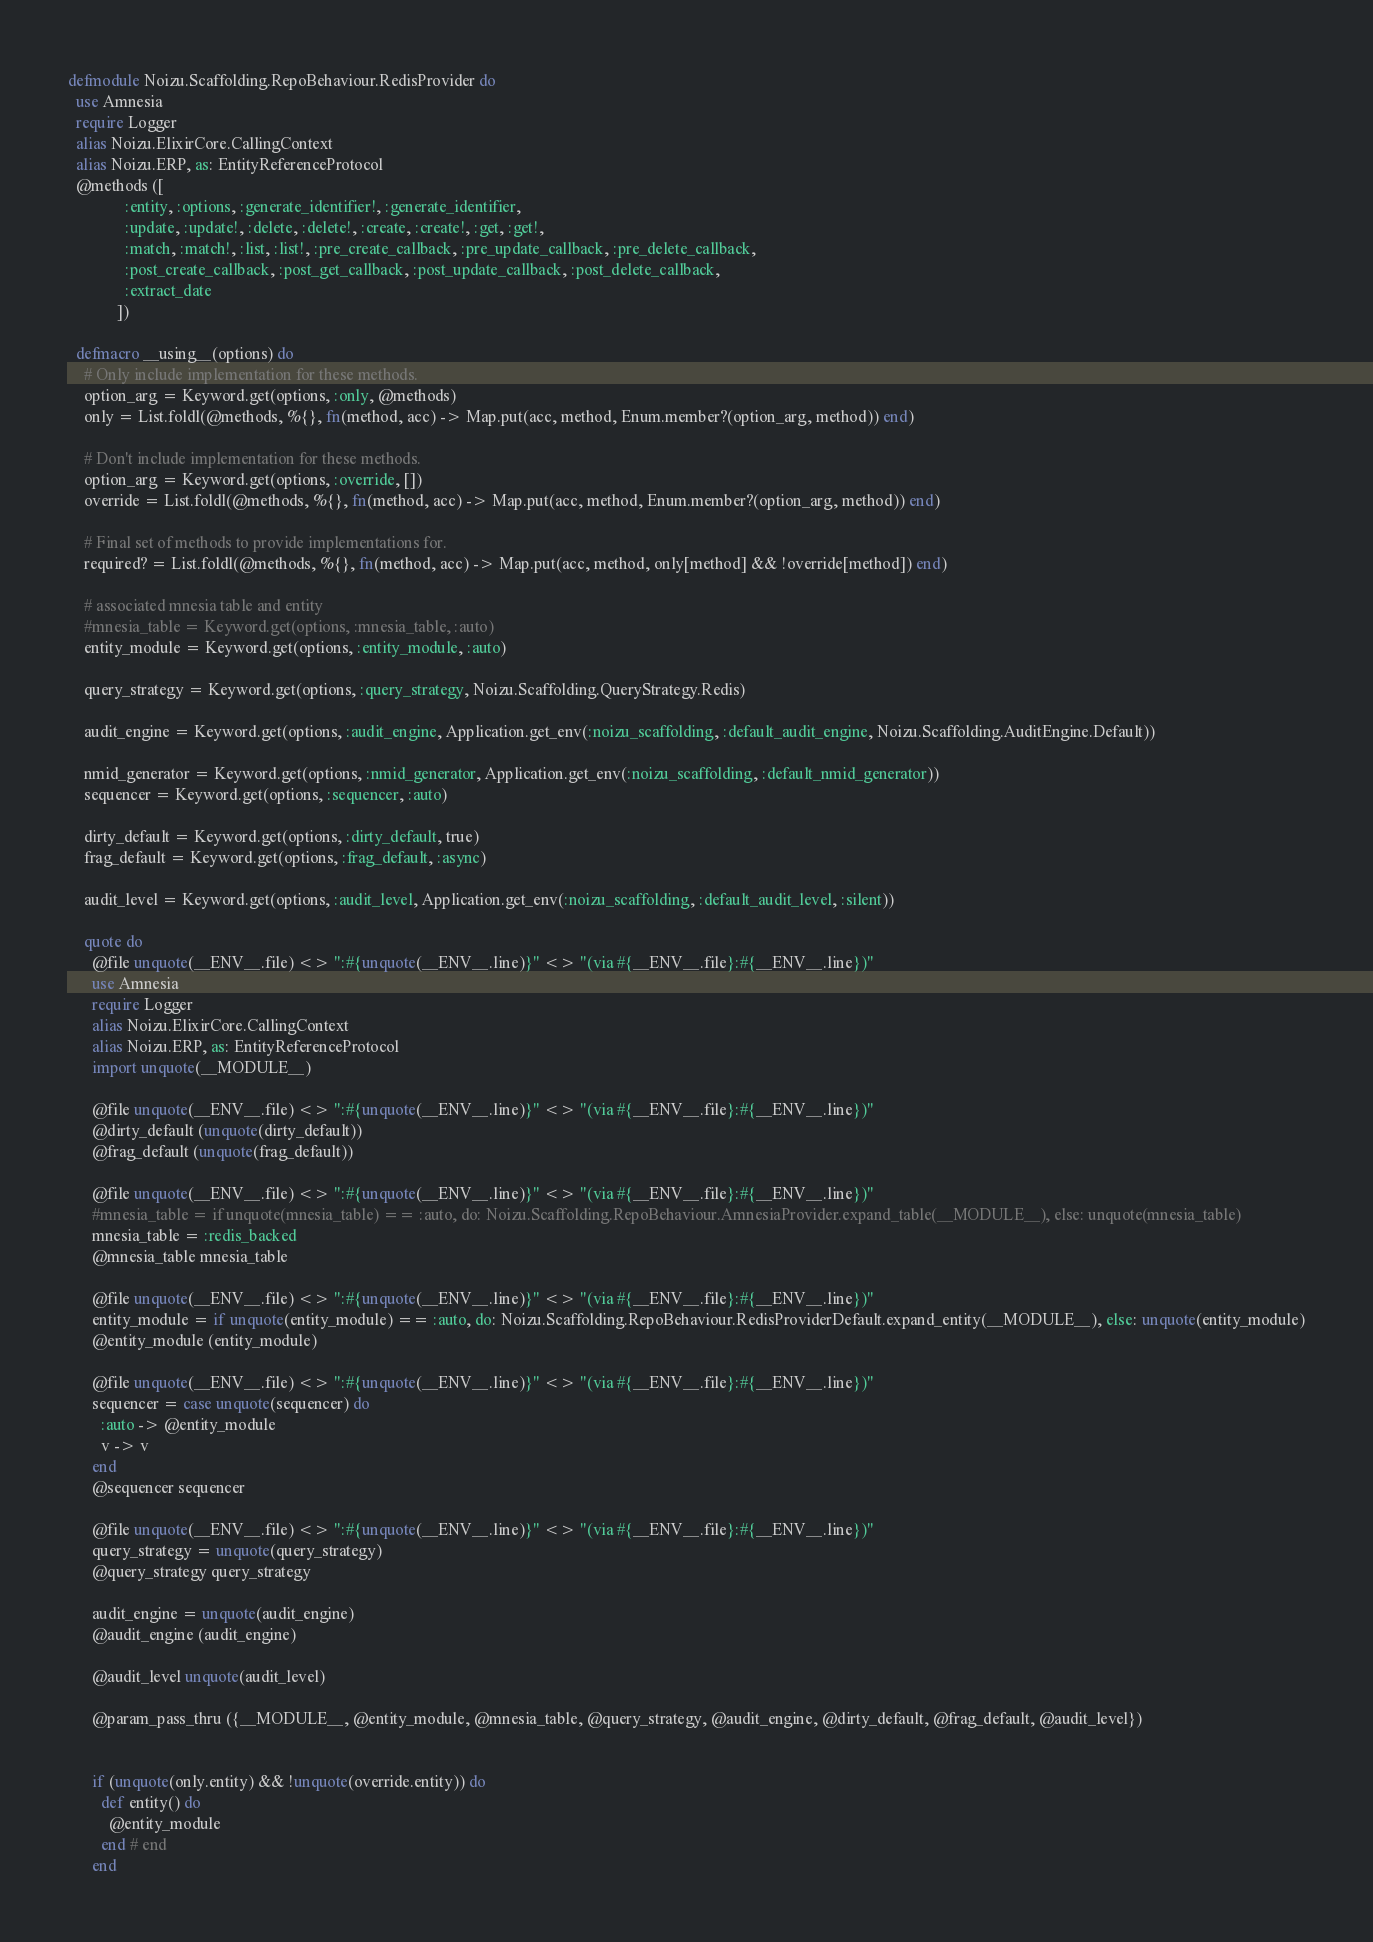<code> <loc_0><loc_0><loc_500><loc_500><_Elixir_>defmodule Noizu.Scaffolding.RepoBehaviour.RedisProvider do
  use Amnesia
  require Logger
  alias Noizu.ElixirCore.CallingContext
  alias Noizu.ERP, as: EntityReferenceProtocol
  @methods ([
              :entity, :options, :generate_identifier!, :generate_identifier,
              :update, :update!, :delete, :delete!, :create, :create!, :get, :get!,
              :match, :match!, :list, :list!, :pre_create_callback, :pre_update_callback, :pre_delete_callback,
              :post_create_callback, :post_get_callback, :post_update_callback, :post_delete_callback,
              :extract_date
            ])

  defmacro __using__(options) do
    # Only include implementation for these methods.
    option_arg = Keyword.get(options, :only, @methods)
    only = List.foldl(@methods, %{}, fn(method, acc) -> Map.put(acc, method, Enum.member?(option_arg, method)) end)

    # Don't include implementation for these methods.
    option_arg = Keyword.get(options, :override, [])
    override = List.foldl(@methods, %{}, fn(method, acc) -> Map.put(acc, method, Enum.member?(option_arg, method)) end)

    # Final set of methods to provide implementations for.
    required? = List.foldl(@methods, %{}, fn(method, acc) -> Map.put(acc, method, only[method] && !override[method]) end)

    # associated mnesia table and entity
    #mnesia_table = Keyword.get(options, :mnesia_table, :auto)
    entity_module = Keyword.get(options, :entity_module, :auto)

    query_strategy = Keyword.get(options, :query_strategy, Noizu.Scaffolding.QueryStrategy.Redis)

    audit_engine = Keyword.get(options, :audit_engine, Application.get_env(:noizu_scaffolding, :default_audit_engine, Noizu.Scaffolding.AuditEngine.Default))

    nmid_generator = Keyword.get(options, :nmid_generator, Application.get_env(:noizu_scaffolding, :default_nmid_generator))
    sequencer = Keyword.get(options, :sequencer, :auto)

    dirty_default = Keyword.get(options, :dirty_default, true)
    frag_default = Keyword.get(options, :frag_default, :async)

    audit_level = Keyword.get(options, :audit_level, Application.get_env(:noizu_scaffolding, :default_audit_level, :silent))

    quote do
      @file unquote(__ENV__.file) <> ":#{unquote(__ENV__.line)}" <> "(via #{__ENV__.file}:#{__ENV__.line})"
      use Amnesia
      require Logger
      alias Noizu.ElixirCore.CallingContext
      alias Noizu.ERP, as: EntityReferenceProtocol
      import unquote(__MODULE__)

      @file unquote(__ENV__.file) <> ":#{unquote(__ENV__.line)}" <> "(via #{__ENV__.file}:#{__ENV__.line})"
      @dirty_default (unquote(dirty_default))
      @frag_default (unquote(frag_default))

      @file unquote(__ENV__.file) <> ":#{unquote(__ENV__.line)}" <> "(via #{__ENV__.file}:#{__ENV__.line})"
      #mnesia_table = if unquote(mnesia_table) == :auto, do: Noizu.Scaffolding.RepoBehaviour.AmnesiaProvider.expand_table(__MODULE__), else: unquote(mnesia_table)
      mnesia_table = :redis_backed
      @mnesia_table mnesia_table

      @file unquote(__ENV__.file) <> ":#{unquote(__ENV__.line)}" <> "(via #{__ENV__.file}:#{__ENV__.line})"
      entity_module = if unquote(entity_module) == :auto, do: Noizu.Scaffolding.RepoBehaviour.RedisProviderDefault.expand_entity(__MODULE__), else: unquote(entity_module)
      @entity_module (entity_module)

      @file unquote(__ENV__.file) <> ":#{unquote(__ENV__.line)}" <> "(via #{__ENV__.file}:#{__ENV__.line})"
      sequencer = case unquote(sequencer) do
        :auto -> @entity_module
        v -> v
      end
      @sequencer sequencer

      @file unquote(__ENV__.file) <> ":#{unquote(__ENV__.line)}" <> "(via #{__ENV__.file}:#{__ENV__.line})"
      query_strategy = unquote(query_strategy)
      @query_strategy query_strategy

      audit_engine = unquote(audit_engine)
      @audit_engine (audit_engine)

      @audit_level unquote(audit_level)

      @param_pass_thru ({__MODULE__, @entity_module, @mnesia_table, @query_strategy, @audit_engine, @dirty_default, @frag_default, @audit_level})


      if (unquote(only.entity) && !unquote(override.entity)) do
        def entity() do
          @entity_module
        end # end
      end
</code> 